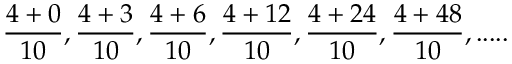Convert formula to latex. <formula><loc_0><loc_0><loc_500><loc_500>{ \frac { 4 + 0 } { 1 0 } } , { \frac { 4 + 3 } { 1 0 } } , { \frac { 4 + 6 } { 1 0 } } , { \frac { 4 + 1 2 } { 1 0 } } , { \frac { 4 + 2 4 } { 1 0 } } , { \frac { 4 + 4 8 } { 1 0 } } , \cdots .</formula> 